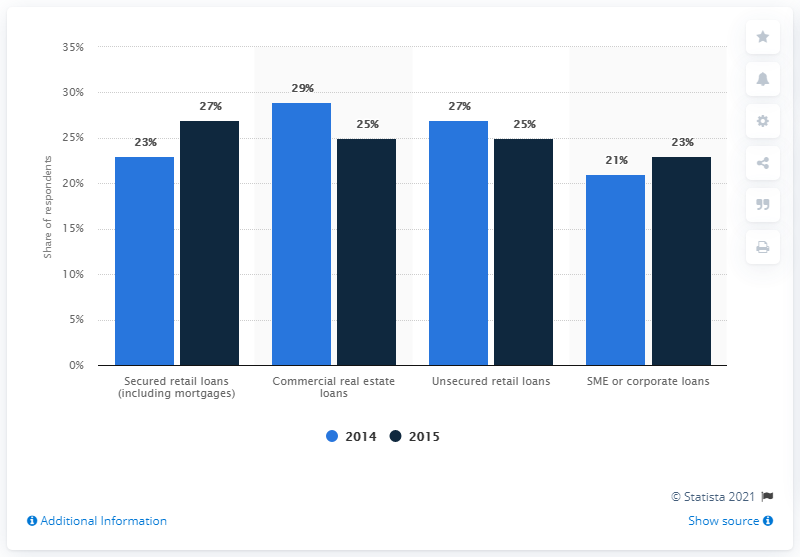Specify some key components in this picture. In 2014, the share of secured retail non-performing loans was 23%. In 2015, the second most popular investment type was... 